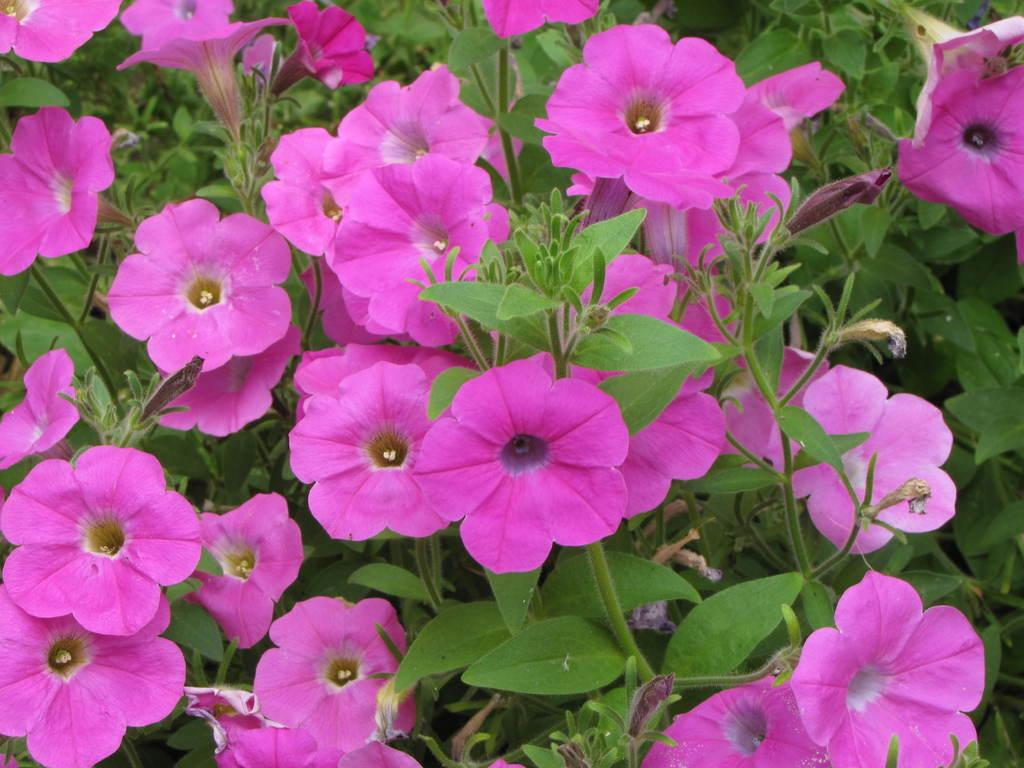What type of plant life can be seen in the image? There are flowers and leaves in the image. Can you describe the flowers in the image? Unfortunately, the facts provided do not give specific details about the flowers. Are there any other elements in the image besides the flowers and leaves? The facts provided do not mention any other elements in the image. Can you hear the sister laughing in the image? There is no mention of a sister or laughter in the image, as the facts provided only mention flowers and leaves. 